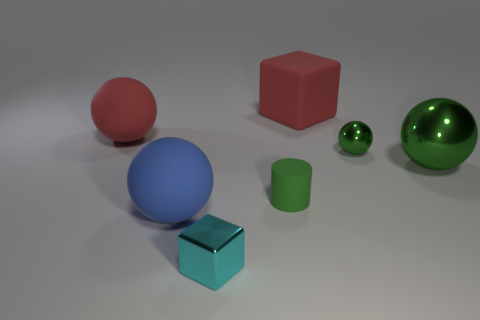Subtract all blue balls. How many balls are left? 3 Subtract all blue balls. How many balls are left? 3 Subtract all yellow cubes. How many green spheres are left? 2 Add 1 small things. How many objects exist? 8 Subtract all purple balls. Subtract all purple cylinders. How many balls are left? 4 Add 5 big red things. How many big red things exist? 7 Subtract 0 gray cubes. How many objects are left? 7 Subtract all balls. How many objects are left? 3 Subtract all yellow matte cylinders. Subtract all green matte things. How many objects are left? 6 Add 4 large blue matte things. How many large blue matte things are left? 5 